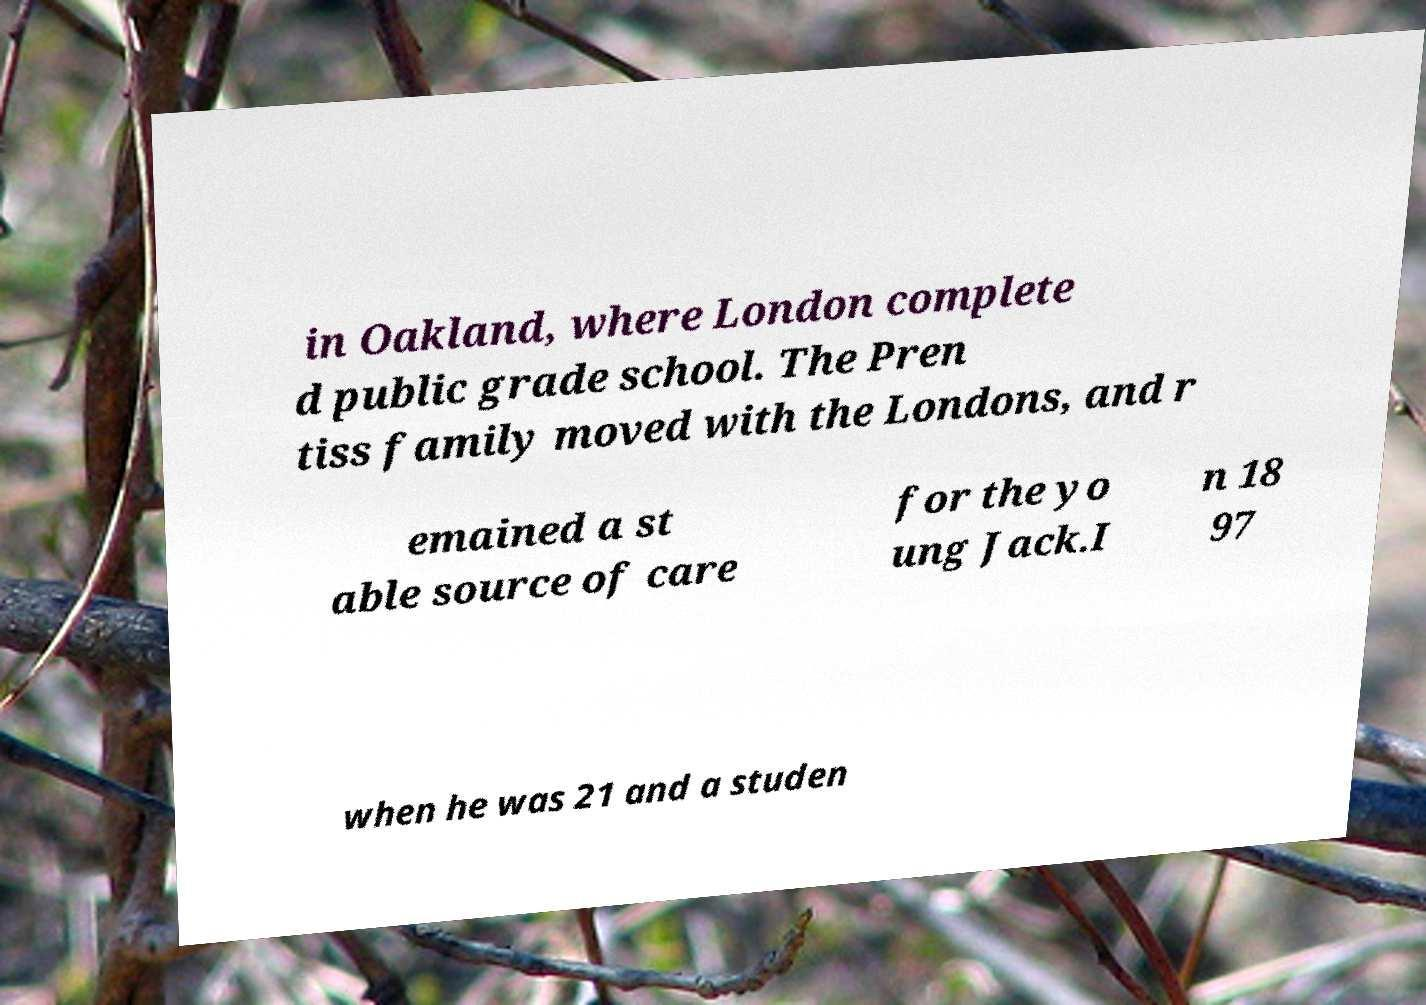I need the written content from this picture converted into text. Can you do that? in Oakland, where London complete d public grade school. The Pren tiss family moved with the Londons, and r emained a st able source of care for the yo ung Jack.I n 18 97 when he was 21 and a studen 